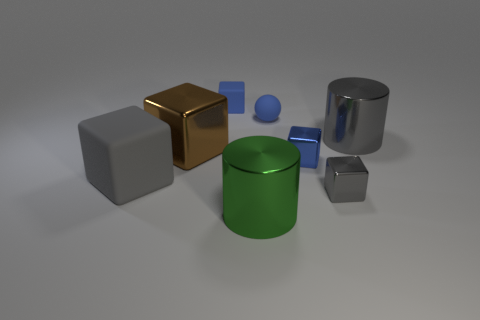Add 1 large brown metallic cubes. How many objects exist? 9 Subtract all blue cylinders. How many blue blocks are left? 2 Subtract all tiny blue rubber cubes. How many cubes are left? 4 Subtract 4 cubes. How many cubes are left? 1 Subtract all brown cubes. How many cubes are left? 4 Subtract all cubes. How many objects are left? 3 Subtract all yellow cylinders. Subtract all cyan cubes. How many cylinders are left? 2 Subtract all big green shiny cylinders. Subtract all tiny red metal objects. How many objects are left? 7 Add 5 small matte spheres. How many small matte spheres are left? 6 Add 8 gray blocks. How many gray blocks exist? 10 